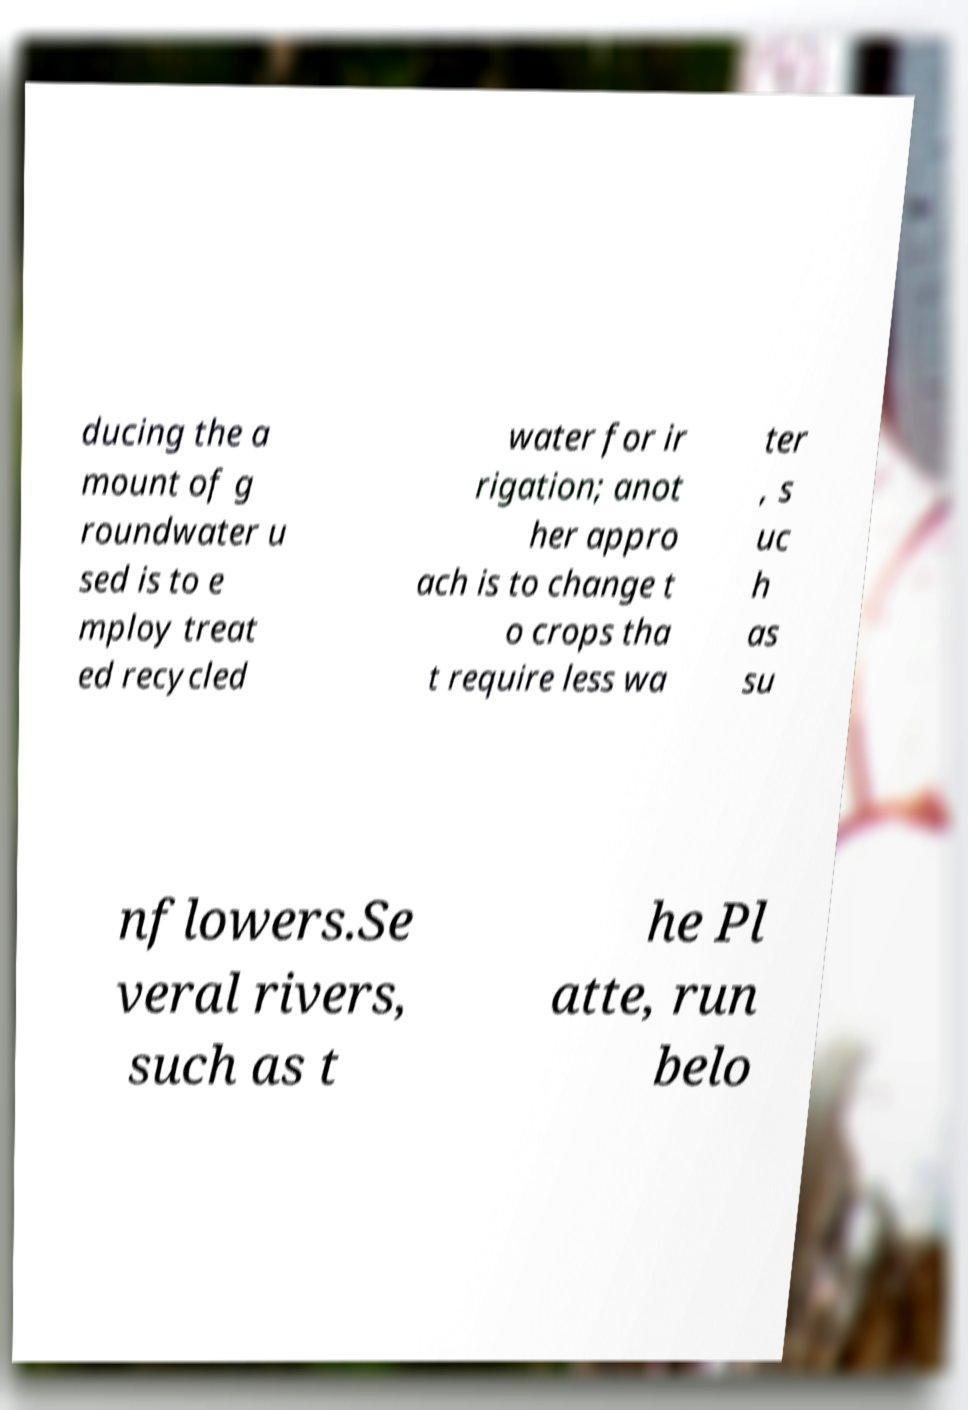Could you assist in decoding the text presented in this image and type it out clearly? ducing the a mount of g roundwater u sed is to e mploy treat ed recycled water for ir rigation; anot her appro ach is to change t o crops tha t require less wa ter , s uc h as su nflowers.Se veral rivers, such as t he Pl atte, run belo 